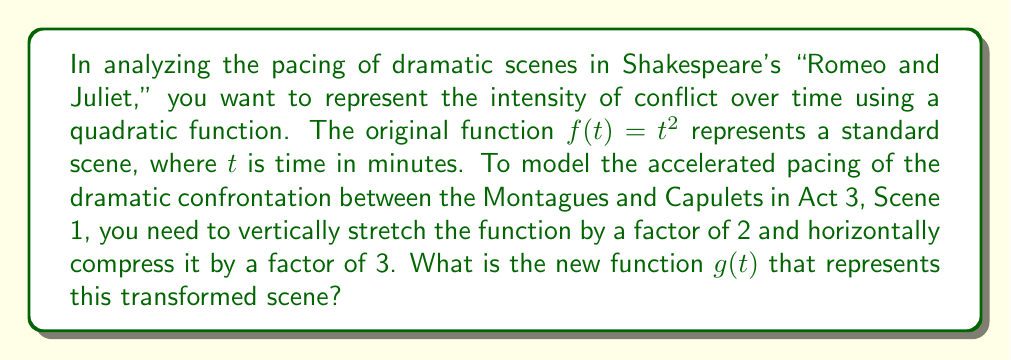Can you answer this question? To solve this problem, we need to apply the principles of function transformations:

1. Vertical stretch: Multiplying the function by a factor of 2
   $f(t) = t^2$ becomes $2t^2$

2. Horizontal compression: Replacing $t$ with $3t$
   $2t^2$ becomes $2(3t)^2$

Let's break down the steps:

a) Start with the original function: $f(t) = t^2$

b) Apply the vertical stretch:
   $2f(t) = 2t^2$

c) Apply the horizontal compression:
   $g(t) = 2(3t)^2$

d) Simplify:
   $g(t) = 2(9t^2) = 18t^2$

Therefore, the new function $g(t)$ that represents the transformed scene is $g(t) = 18t^2$.

This transformation effectively increases the rate at which the intensity of the scene grows over time, reflecting the heightened drama and faster pacing of the confrontation scene.
Answer: $g(t) = 18t^2$ 